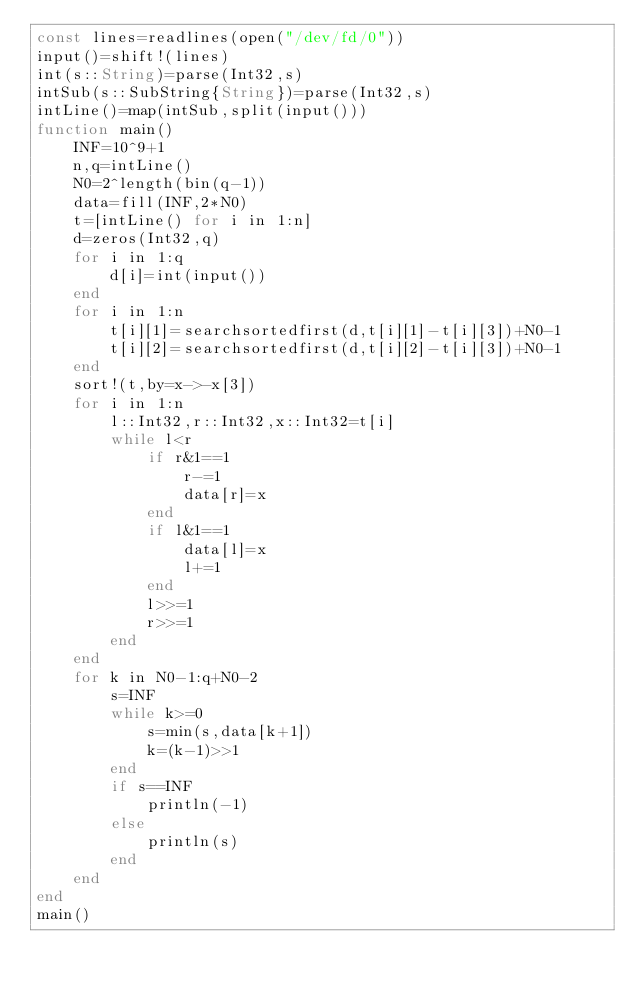Convert code to text. <code><loc_0><loc_0><loc_500><loc_500><_Julia_>const lines=readlines(open("/dev/fd/0"))
input()=shift!(lines)
int(s::String)=parse(Int32,s)
intSub(s::SubString{String})=parse(Int32,s)
intLine()=map(intSub,split(input()))
function main()
    INF=10^9+1
    n,q=intLine()
    N0=2^length(bin(q-1))
    data=fill(INF,2*N0)
    t=[intLine() for i in 1:n]
    d=zeros(Int32,q)
    for i in 1:q
        d[i]=int(input())
    end
    for i in 1:n
        t[i][1]=searchsortedfirst(d,t[i][1]-t[i][3])+N0-1
        t[i][2]=searchsortedfirst(d,t[i][2]-t[i][3])+N0-1
    end
    sort!(t,by=x->-x[3])
    for i in 1:n
        l::Int32,r::Int32,x::Int32=t[i]
        while l<r
            if r&1==1
                r-=1
                data[r]=x
            end
            if l&1==1
                data[l]=x
                l+=1
            end
            l>>=1
            r>>=1
        end
    end
    for k in N0-1:q+N0-2
        s=INF
        while k>=0
            s=min(s,data[k+1])
            k=(k-1)>>1
        end
        if s==INF
            println(-1)
        else
            println(s)
        end
    end
end
main()</code> 